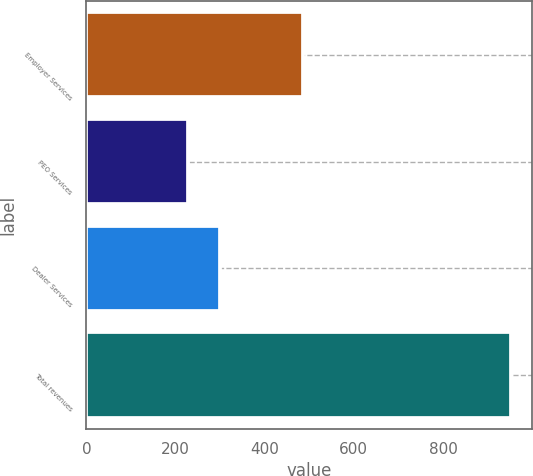<chart> <loc_0><loc_0><loc_500><loc_500><bar_chart><fcel>Employer Services<fcel>PEO Services<fcel>Dealer Services<fcel>Total revenues<nl><fcel>485<fcel>227.1<fcel>299.57<fcel>951.8<nl></chart> 